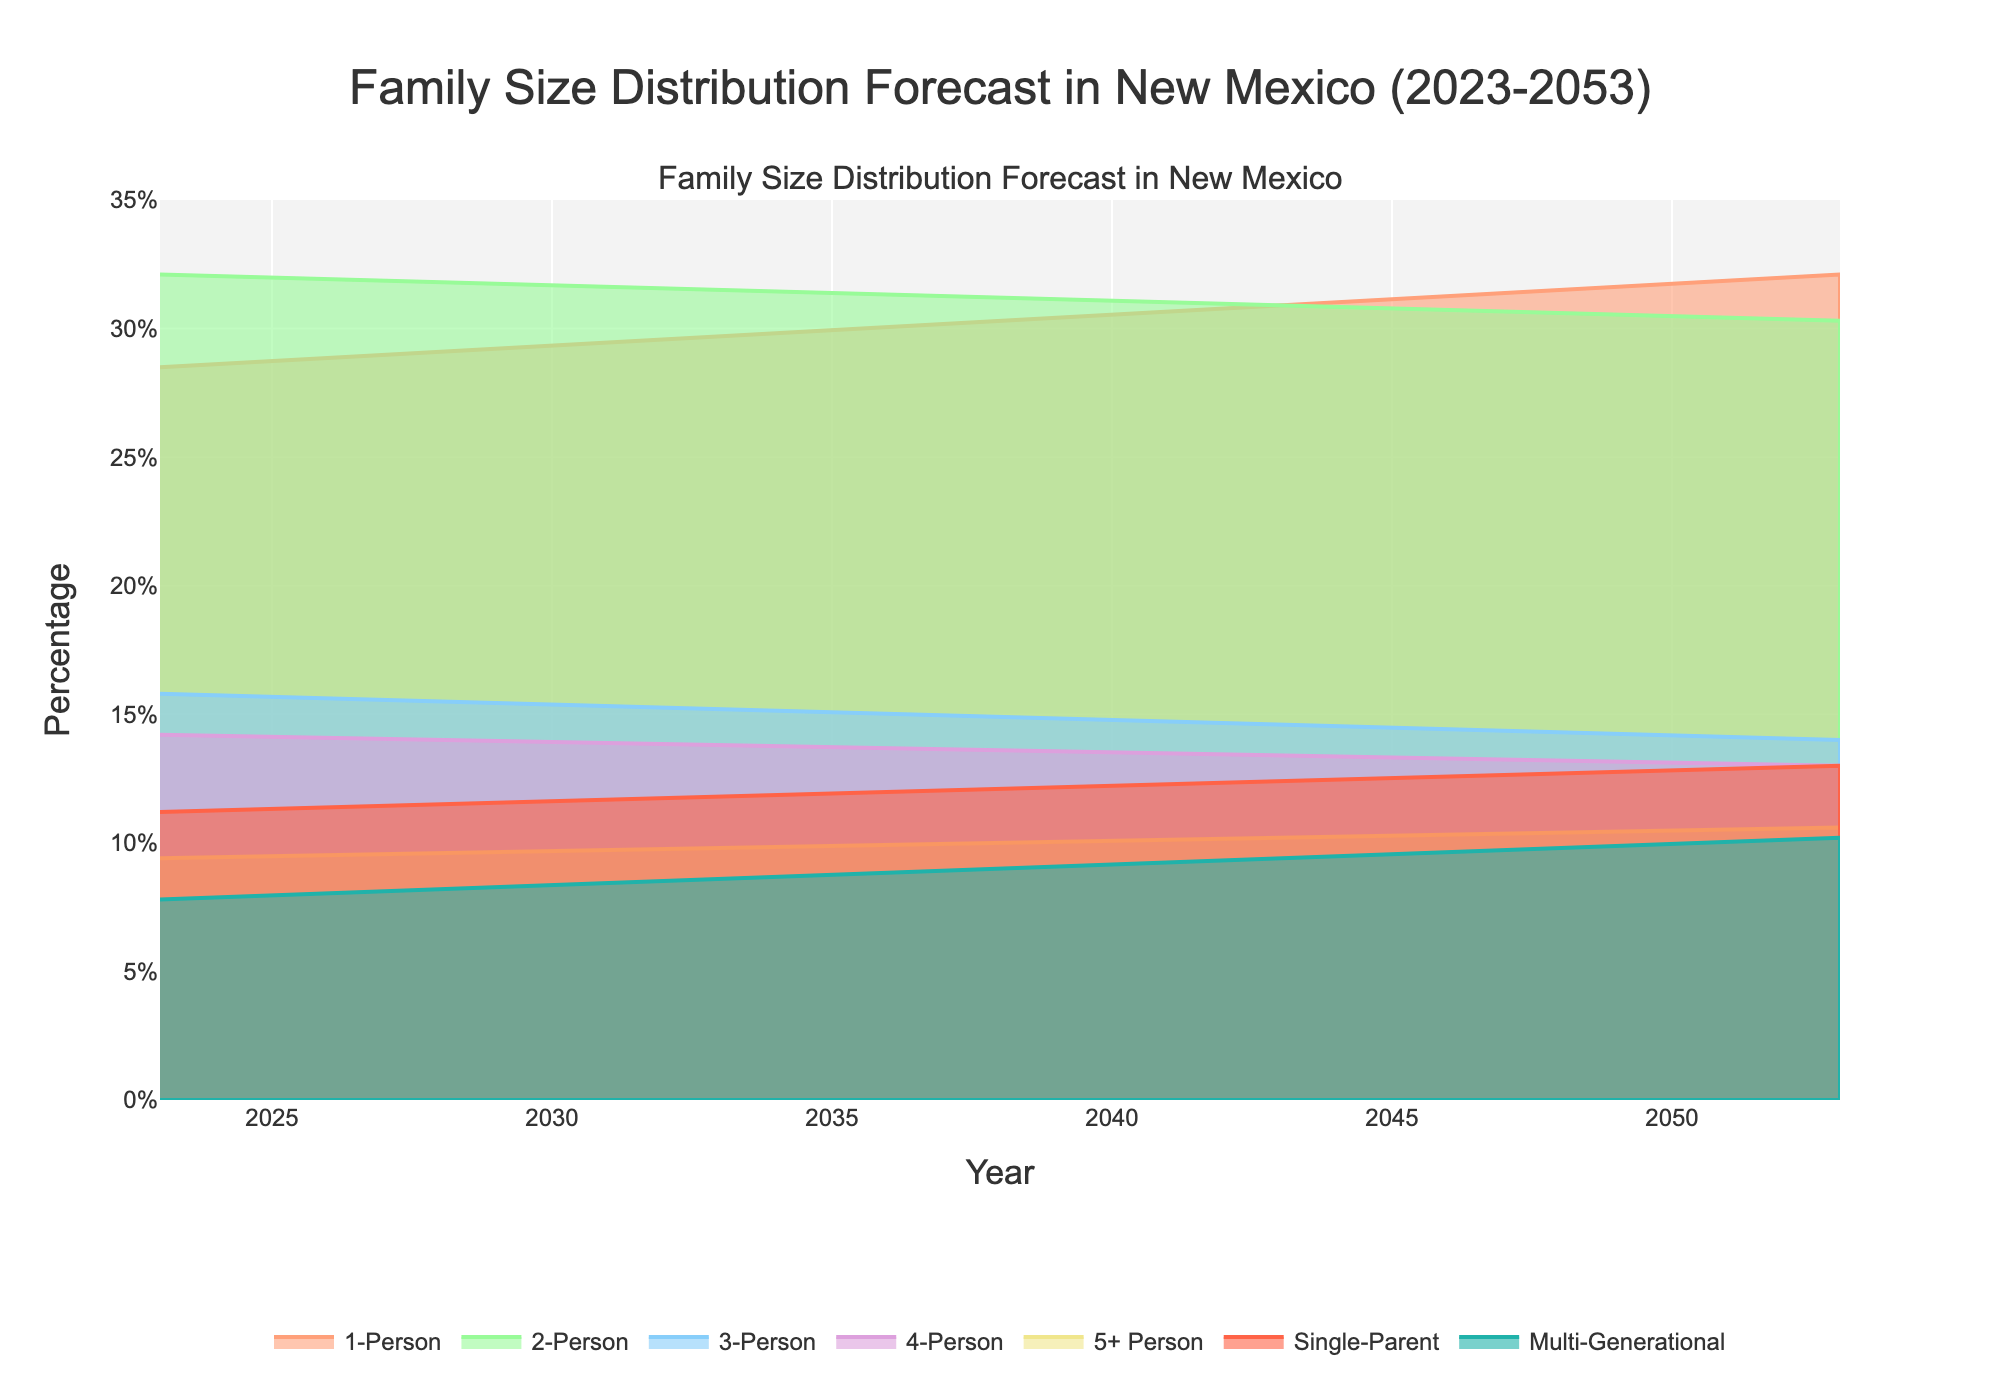what is the title of the chart? The title can usually be found at the top of the chart. In this case, it clearly states "Family Size Distribution Forecast in New Mexico (2023-2053)".
Answer: Family Size Distribution Forecast in New Mexico (2023-2053) what does the x-axis represent? The x-axis typically represents the variable that is changing over time or categories. Here, it denotes the years from 2023 to 2053.
Answer: Years which family size has the highest proportion in 2023? By observing the distribution in 2023, we can see that the largest band is for "2-Person" households, indicating the highest percentage.
Answer: 2-Person What's the general trend for 1-Person households over the years? Looking at the fan chart, the area representing 1-Person households gradually increases from 2023 to 2053. This indicates a growing trend.
Answer: Increasing How do the projections for Single-Parent households change from 2023 to 2053? By examining the Single-Parent band in the chart, it shows a continuous increase in percentage, from 11.2% in 2023 to 13.0% in 2053.
Answer: Increasing Which family size category is projected to decrease the most in the next 30 years? Observing the different bands, the "2-Person" households show the most noticeable decrease, going from 32.1% in 2023 to 30.3% in 2053.
Answer: 2-Person How does the percentage of Multi-Generational households change from 2023 to 2053? By noting the Multi-Generational band over time, it shows a consistent increase from 7.8% in 2023 to 10.2% in 2053.
Answer: Increasing What's the difference in the percentage of 4-Person households between 2023 and 2053? By computing the values from the chart, in 2023 it stands at 14.2% and in 2053 it is 13.0%, so the difference is 14.2 - 13.0 = 1.2%.
Answer: 1.2% Which family size category remains relatively stable over the 30 years? Observing closely, the "3-Person" households have a slight decline but overall remain quite stable compared to others, from 15.8% in 2023 to 14.0% in 2053.
Answer: 3-Person 